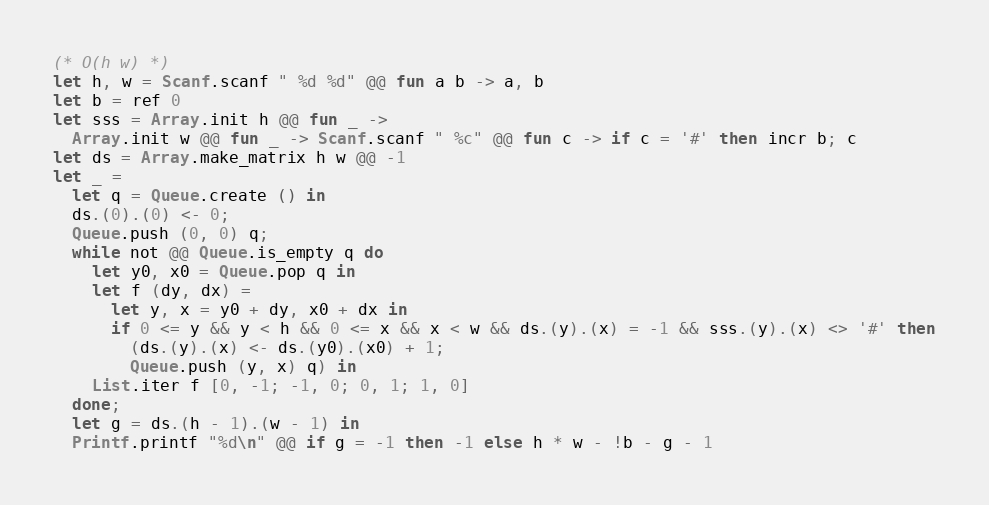<code> <loc_0><loc_0><loc_500><loc_500><_OCaml_>(* O(h w) *)
let h, w = Scanf.scanf " %d %d" @@ fun a b -> a, b
let b = ref 0
let sss = Array.init h @@ fun _ ->
  Array.init w @@ fun _ -> Scanf.scanf " %c" @@ fun c -> if c = '#' then incr b; c
let ds = Array.make_matrix h w @@ -1
let _ =
  let q = Queue.create () in
  ds.(0).(0) <- 0;
  Queue.push (0, 0) q;
  while not @@ Queue.is_empty q do
    let y0, x0 = Queue.pop q in
    let f (dy, dx) =
      let y, x = y0 + dy, x0 + dx in
      if 0 <= y && y < h && 0 <= x && x < w && ds.(y).(x) = -1 && sss.(y).(x) <> '#' then
        (ds.(y).(x) <- ds.(y0).(x0) + 1;
        Queue.push (y, x) q) in
    List.iter f [0, -1; -1, 0; 0, 1; 1, 0]
  done;
  let g = ds.(h - 1).(w - 1) in
  Printf.printf "%d\n" @@ if g = -1 then -1 else h * w - !b - g - 1</code> 